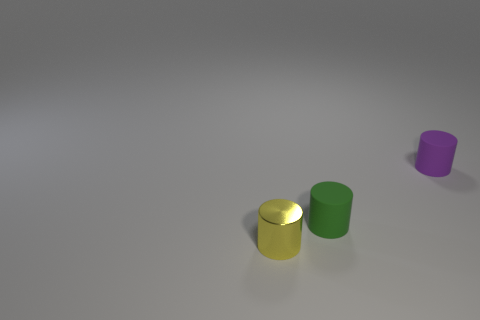Subtract 1 cylinders. How many cylinders are left? 2 Subtract all brown cylinders. Subtract all green blocks. How many cylinders are left? 3 Subtract all gray spheres. How many yellow cylinders are left? 1 Subtract all cyan metal spheres. Subtract all tiny green cylinders. How many objects are left? 2 Add 3 green cylinders. How many green cylinders are left? 4 Add 1 tiny green cylinders. How many tiny green cylinders exist? 2 Add 1 small matte cylinders. How many objects exist? 4 Subtract all purple cylinders. How many cylinders are left? 2 Subtract all purple matte cylinders. How many cylinders are left? 2 Subtract 0 cyan blocks. How many objects are left? 3 